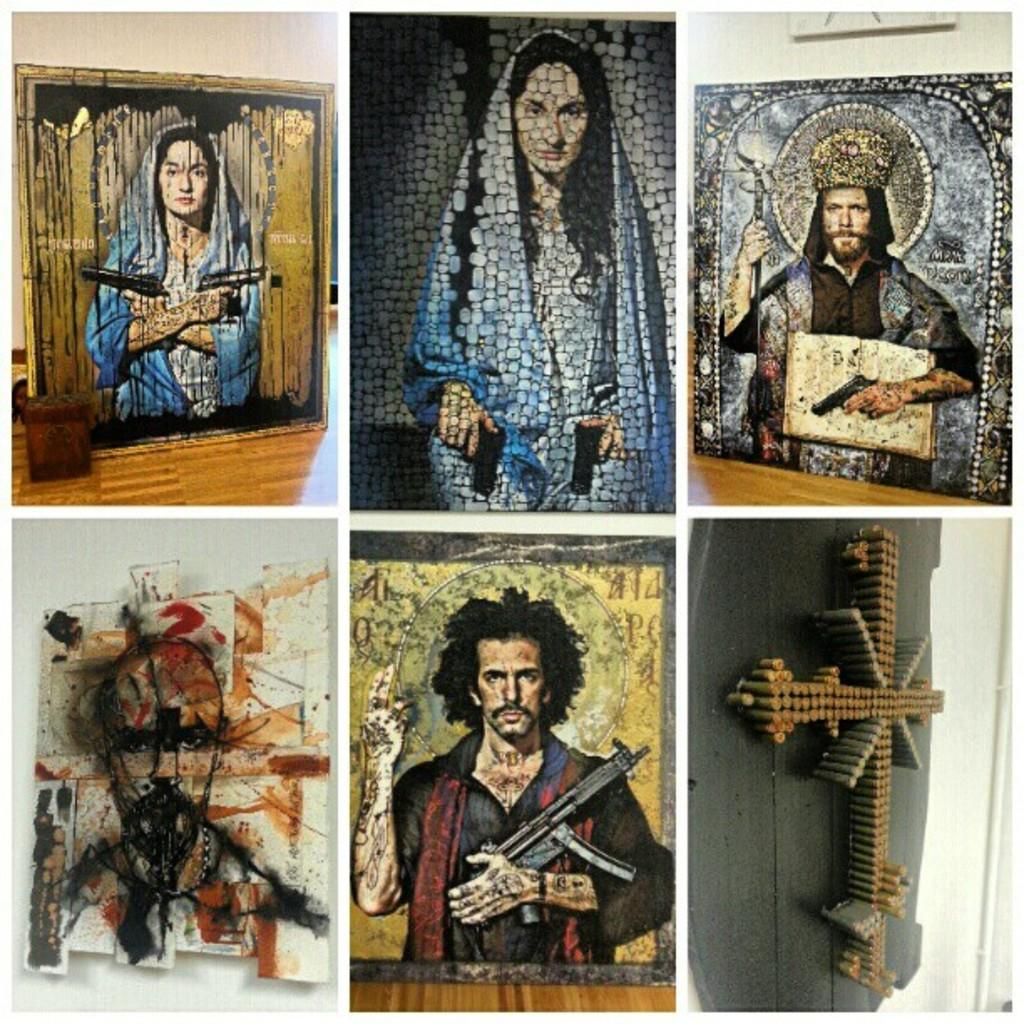What type of artwork is visible in the image? There are paintings in the image. What subjects are depicted in the paintings? The paintings depict two men and two women. Are there any specific symbols or objects in the paintings? Yes, there is a cross in the paintings. What color crayon is being used to draw the lamp in the image? There is no crayon or lamp present in the image; it features paintings depicting two men, two women, and a cross. 